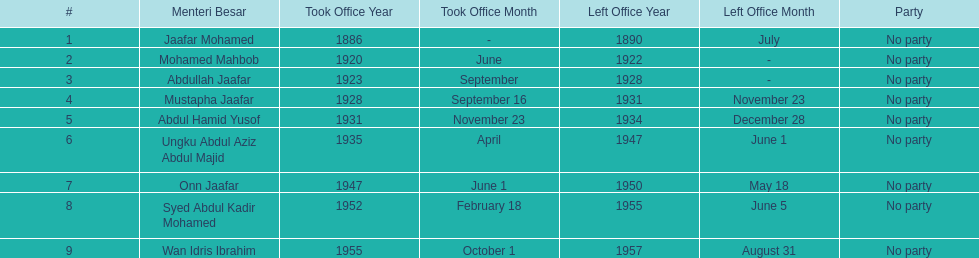Other than abullah jaafar, name someone with the same last name. Mustapha Jaafar. 